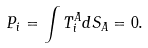<formula> <loc_0><loc_0><loc_500><loc_500>P _ { i } = \int T _ { i } ^ { A } d S _ { A } = 0 .</formula> 